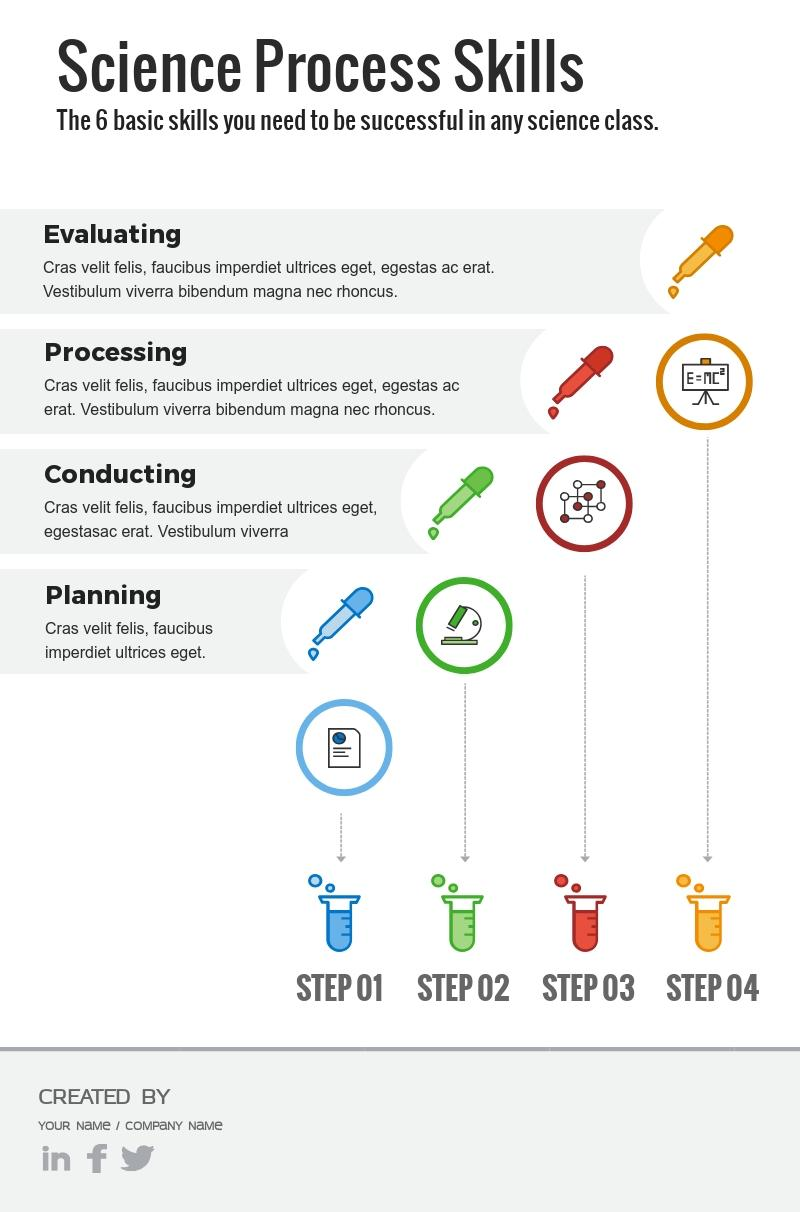Give some essential details in this illustration. The color used to represent "Processing" is blue, green, red, or orange. The color formerly designated as representing the concept of "Evaluating" is now orange. 